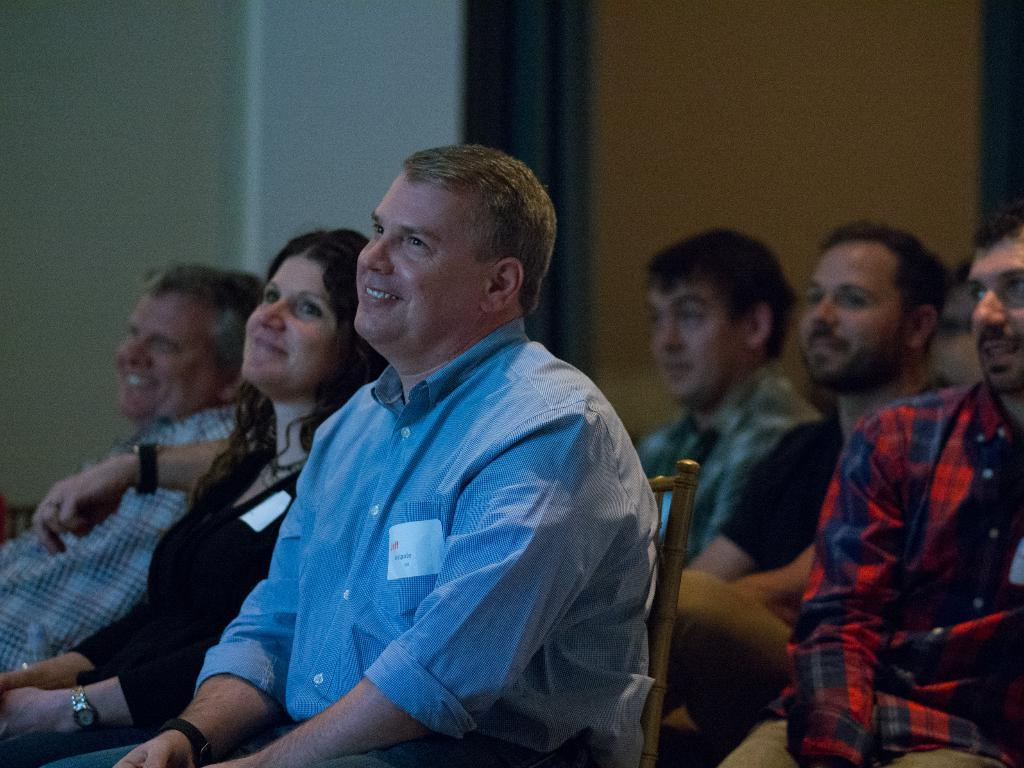What are the people in the image doing? The people in the image are sitting in chairs. Can you describe the man in the foreground of the image? There is a man in a blue shirt in the foreground of the image. What can be seen in the background of the image? There is a wall in the background of the image. What type of sack is being used by the people in the image? There is no sack present in the image; the people are sitting in chairs. What kind of sheet is covering the chairs in the image? There is no sheet covering the chairs in the image; the chairs are visible. 